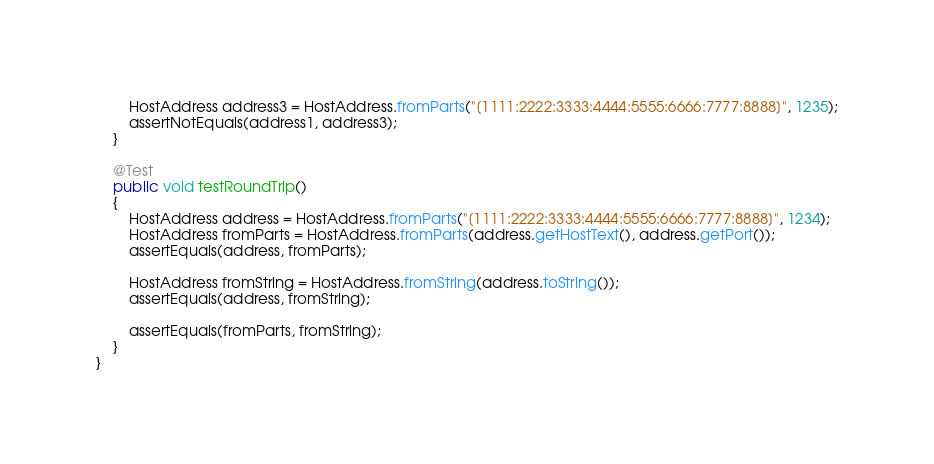Convert code to text. <code><loc_0><loc_0><loc_500><loc_500><_Java_>
        HostAddress address3 = HostAddress.fromParts("[1111:2222:3333:4444:5555:6666:7777:8888]", 1235);
        assertNotEquals(address1, address3);
    }

    @Test
    public void testRoundTrip()
    {
        HostAddress address = HostAddress.fromParts("[1111:2222:3333:4444:5555:6666:7777:8888]", 1234);
        HostAddress fromParts = HostAddress.fromParts(address.getHostText(), address.getPort());
        assertEquals(address, fromParts);

        HostAddress fromString = HostAddress.fromString(address.toString());
        assertEquals(address, fromString);

        assertEquals(fromParts, fromString);
    }
}
</code> 